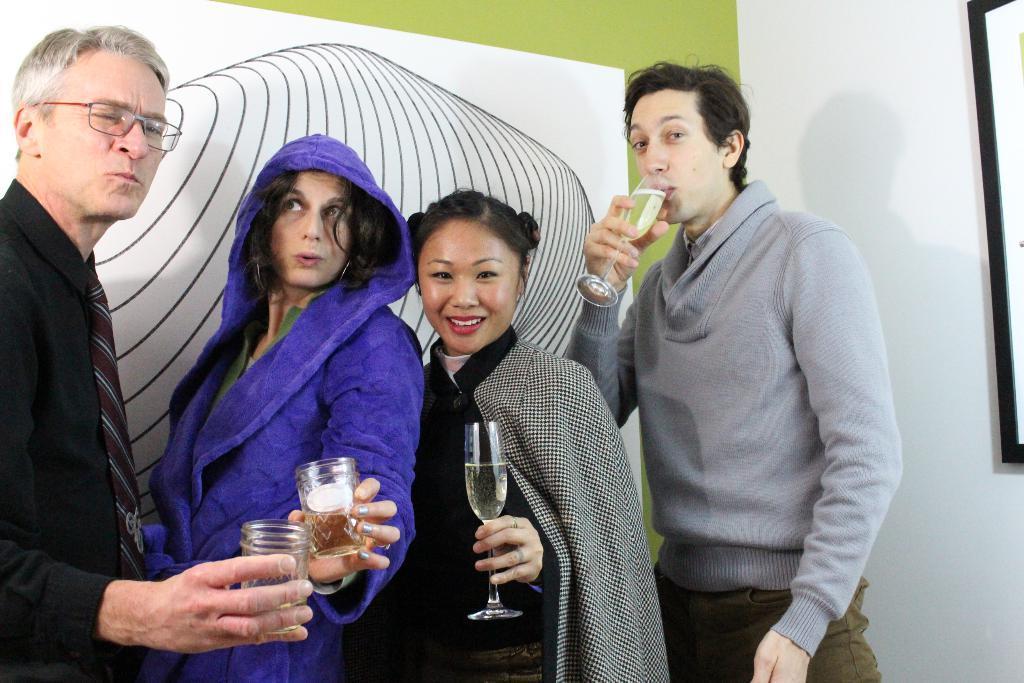In one or two sentences, can you explain what this image depicts? In this picture, we can see a few people holding glass with some liquid in it, we can see the wall with some design. 